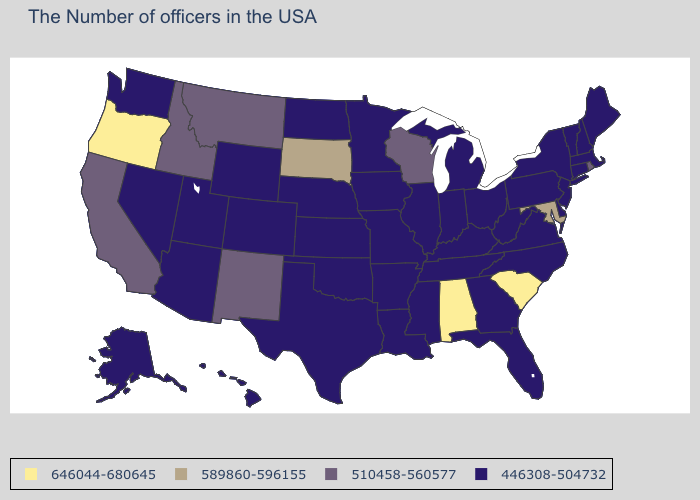Name the states that have a value in the range 589860-596155?
Answer briefly. Maryland, South Dakota. Name the states that have a value in the range 446308-504732?
Short answer required. Maine, Massachusetts, New Hampshire, Vermont, Connecticut, New York, New Jersey, Delaware, Pennsylvania, Virginia, North Carolina, West Virginia, Ohio, Florida, Georgia, Michigan, Kentucky, Indiana, Tennessee, Illinois, Mississippi, Louisiana, Missouri, Arkansas, Minnesota, Iowa, Kansas, Nebraska, Oklahoma, Texas, North Dakota, Wyoming, Colorado, Utah, Arizona, Nevada, Washington, Alaska, Hawaii. What is the highest value in states that border Massachusetts?
Be succinct. 510458-560577. What is the value of Connecticut?
Give a very brief answer. 446308-504732. Does Wisconsin have the lowest value in the USA?
Short answer required. No. Does New Mexico have the lowest value in the West?
Be succinct. No. Which states have the highest value in the USA?
Keep it brief. South Carolina, Alabama, Oregon. Name the states that have a value in the range 446308-504732?
Short answer required. Maine, Massachusetts, New Hampshire, Vermont, Connecticut, New York, New Jersey, Delaware, Pennsylvania, Virginia, North Carolina, West Virginia, Ohio, Florida, Georgia, Michigan, Kentucky, Indiana, Tennessee, Illinois, Mississippi, Louisiana, Missouri, Arkansas, Minnesota, Iowa, Kansas, Nebraska, Oklahoma, Texas, North Dakota, Wyoming, Colorado, Utah, Arizona, Nevada, Washington, Alaska, Hawaii. Name the states that have a value in the range 646044-680645?
Answer briefly. South Carolina, Alabama, Oregon. What is the value of South Dakota?
Concise answer only. 589860-596155. What is the lowest value in states that border Ohio?
Write a very short answer. 446308-504732. Name the states that have a value in the range 446308-504732?
Write a very short answer. Maine, Massachusetts, New Hampshire, Vermont, Connecticut, New York, New Jersey, Delaware, Pennsylvania, Virginia, North Carolina, West Virginia, Ohio, Florida, Georgia, Michigan, Kentucky, Indiana, Tennessee, Illinois, Mississippi, Louisiana, Missouri, Arkansas, Minnesota, Iowa, Kansas, Nebraska, Oklahoma, Texas, North Dakota, Wyoming, Colorado, Utah, Arizona, Nevada, Washington, Alaska, Hawaii. Does Colorado have the highest value in the West?
Keep it brief. No. Does South Dakota have the lowest value in the MidWest?
Concise answer only. No. Which states have the highest value in the USA?
Quick response, please. South Carolina, Alabama, Oregon. 